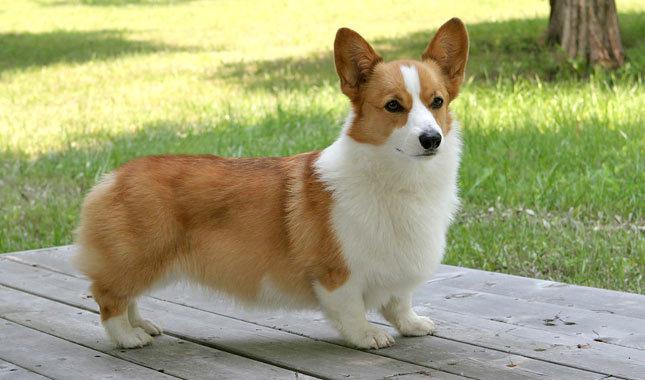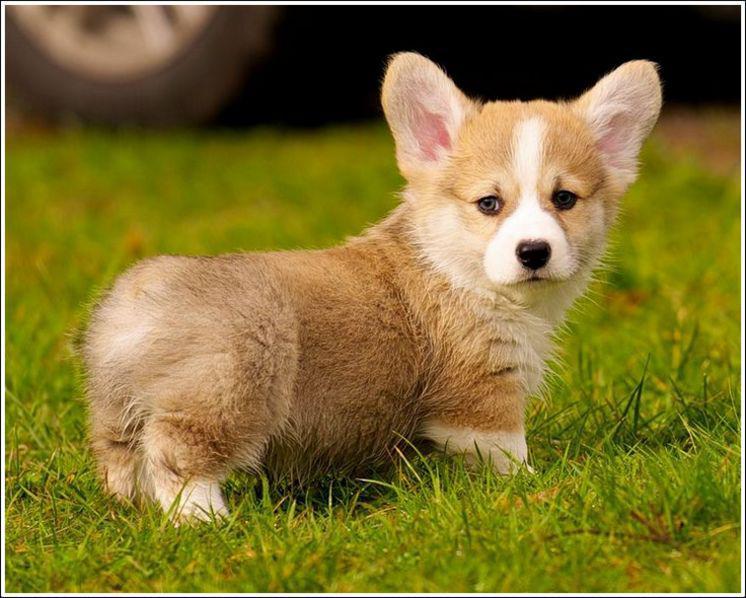The first image is the image on the left, the second image is the image on the right. For the images displayed, is the sentence "At least one image contains only one dog, which is standing on all fours and has its mouth closed." factually correct? Answer yes or no. Yes. The first image is the image on the left, the second image is the image on the right. Given the left and right images, does the statement "One of the dogs is near grass, but not actually IN grass." hold true? Answer yes or no. Yes. 